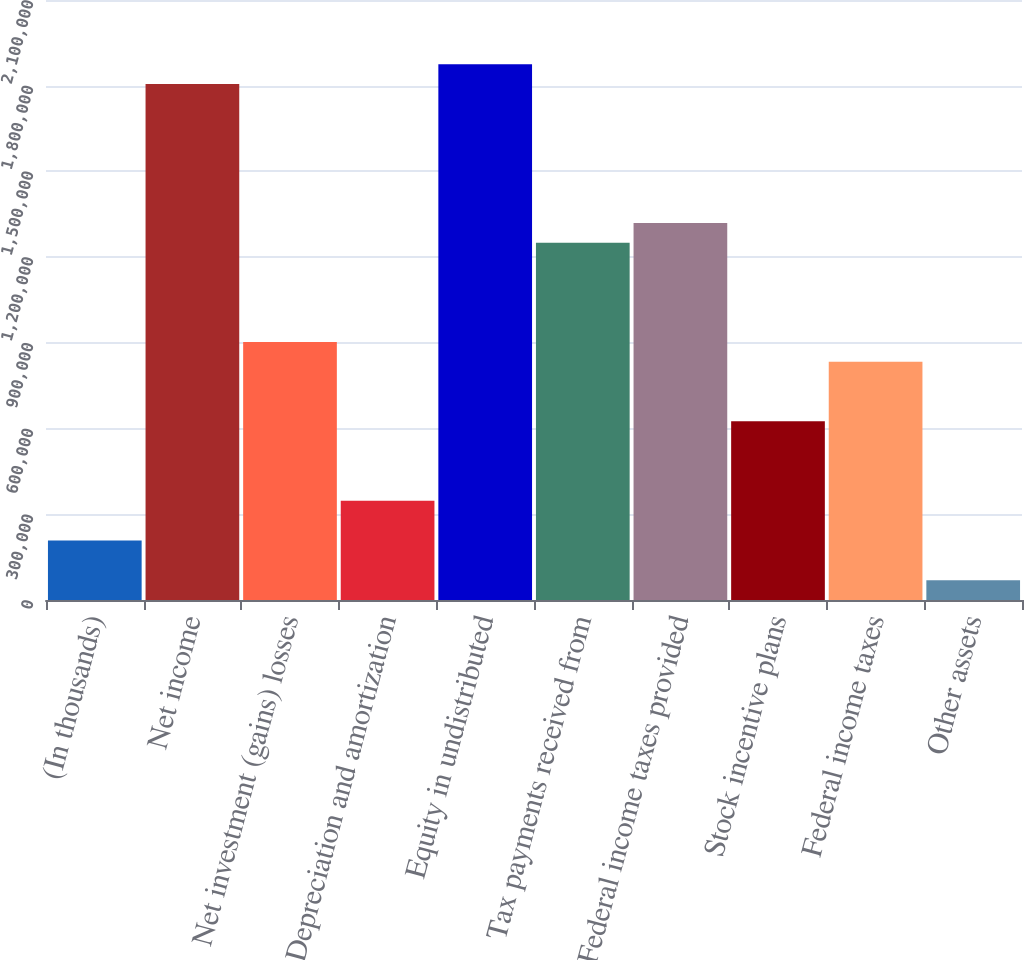Convert chart to OTSL. <chart><loc_0><loc_0><loc_500><loc_500><bar_chart><fcel>(In thousands)<fcel>Net income<fcel>Net investment (gains) losses<fcel>Depreciation and amortization<fcel>Equity in undistributed<fcel>Tax payments received from<fcel>Federal income taxes provided<fcel>Stock incentive plans<fcel>Federal income taxes<fcel>Other assets<nl><fcel>208478<fcel>1.80607e+06<fcel>903082<fcel>347399<fcel>1.87553e+06<fcel>1.25038e+06<fcel>1.31984e+06<fcel>625241<fcel>833622<fcel>69557.4<nl></chart> 